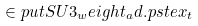Convert formula to latex. <formula><loc_0><loc_0><loc_500><loc_500>\in p u t { S U 3 _ { w } e i g h t _ { a } d . p s t e x _ { t } }</formula> 